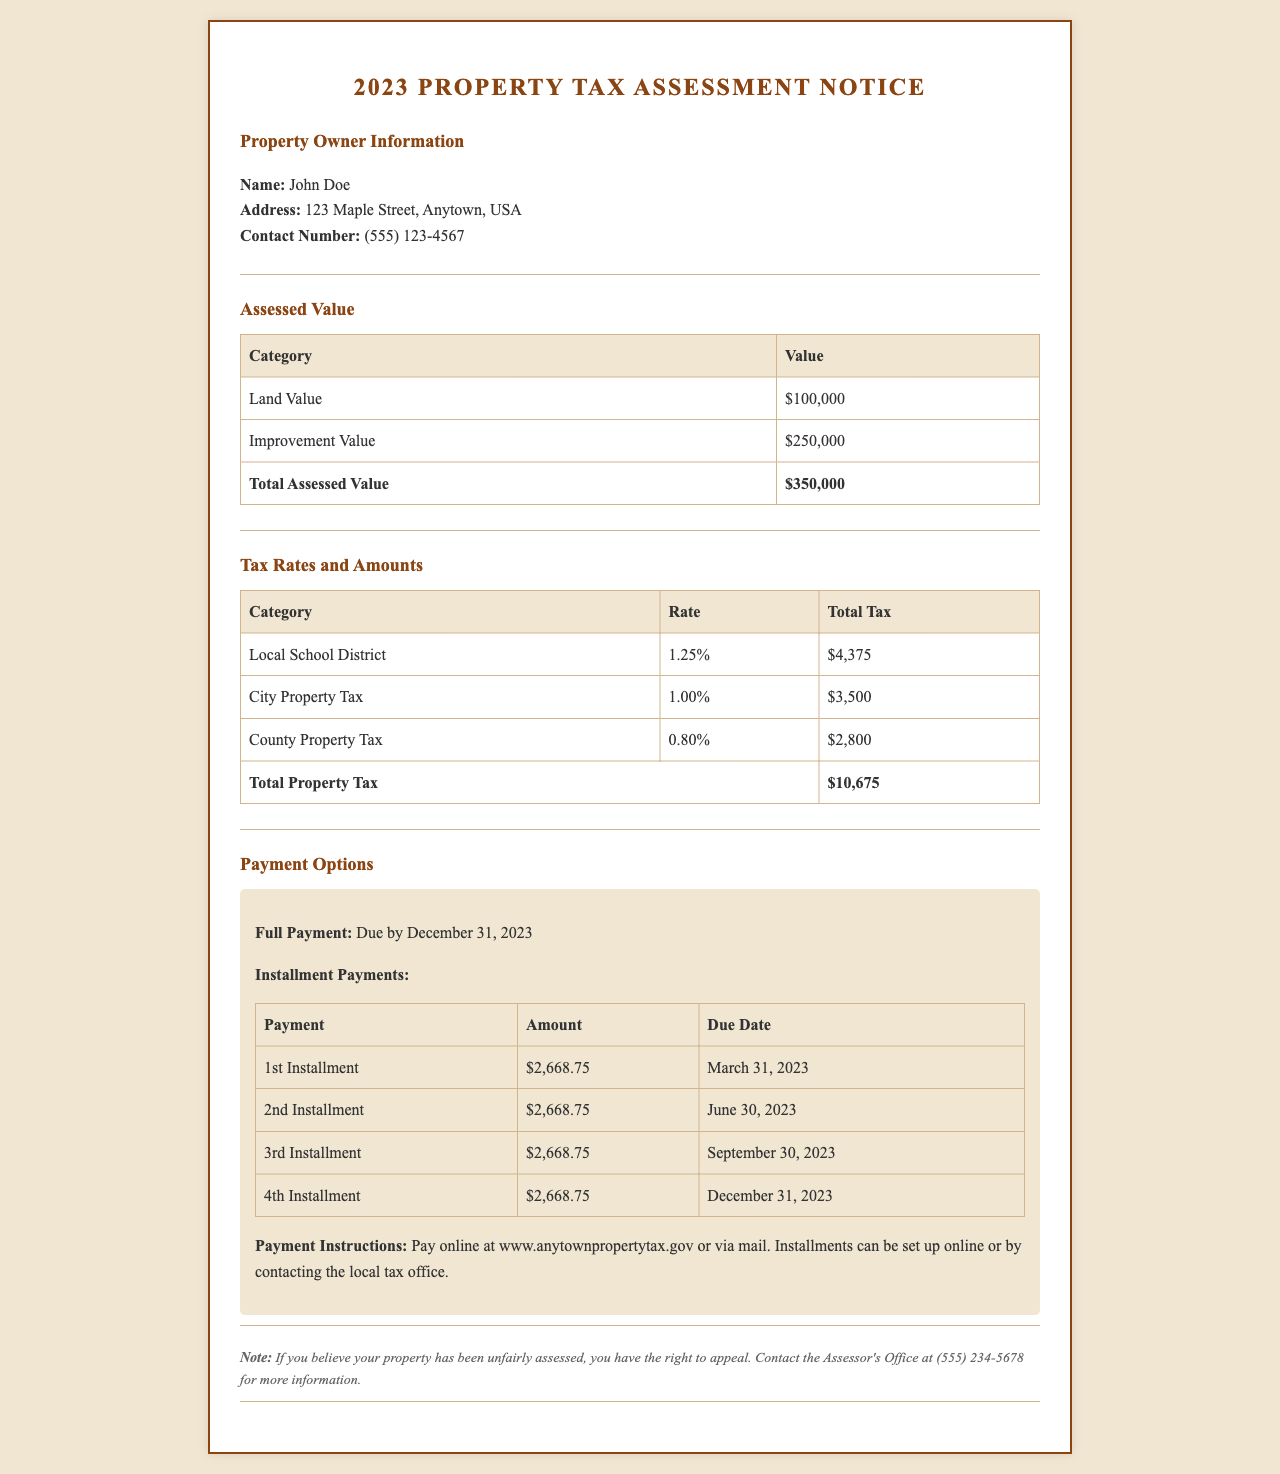What is the name of the property owner? The document states the property owner's name in the 'Property Owner Information' section as John Doe.
Answer: John Doe What is the total assessed value? The total assessed value is explicitly stated in the 'Assessed Value' section as $350,000.
Answer: $350,000 What is the total property tax amount? The 'Tax Rates and Amounts' section summarizes the total property tax amount, which is $10,675.
Answer: $10,675 What is the due date for the full payment? The document specifies the due date for full payment in the 'Payment Options' section as December 31, 2023.
Answer: December 31, 2023 How many installment payments are there? The document outlines four installment payments in the 'Payment Options' section, listed under the payment table.
Answer: Four How much is each installment payment? Each installment payment amount is detailed in the 'Payment Options' section, where it states $2,668.75 per installment.
Answer: $2,668.75 What is the rate for the City Property Tax? The 'Tax Rates and Amounts' section shows that the rate for the City Property Tax is 1.00%.
Answer: 1.00% What is the contact number for the Assessor's Office? The contact number for the Assessor's Office is mentioned in the notes at the end of the document as (555) 234-5678.
Answer: (555) 234-5678 What should you do if you believe the property has been unfairly assessed? The document advises to contact the Assessor's Office for more information regarding appeals in the notes section.
Answer: Contact the Assessor's Office 